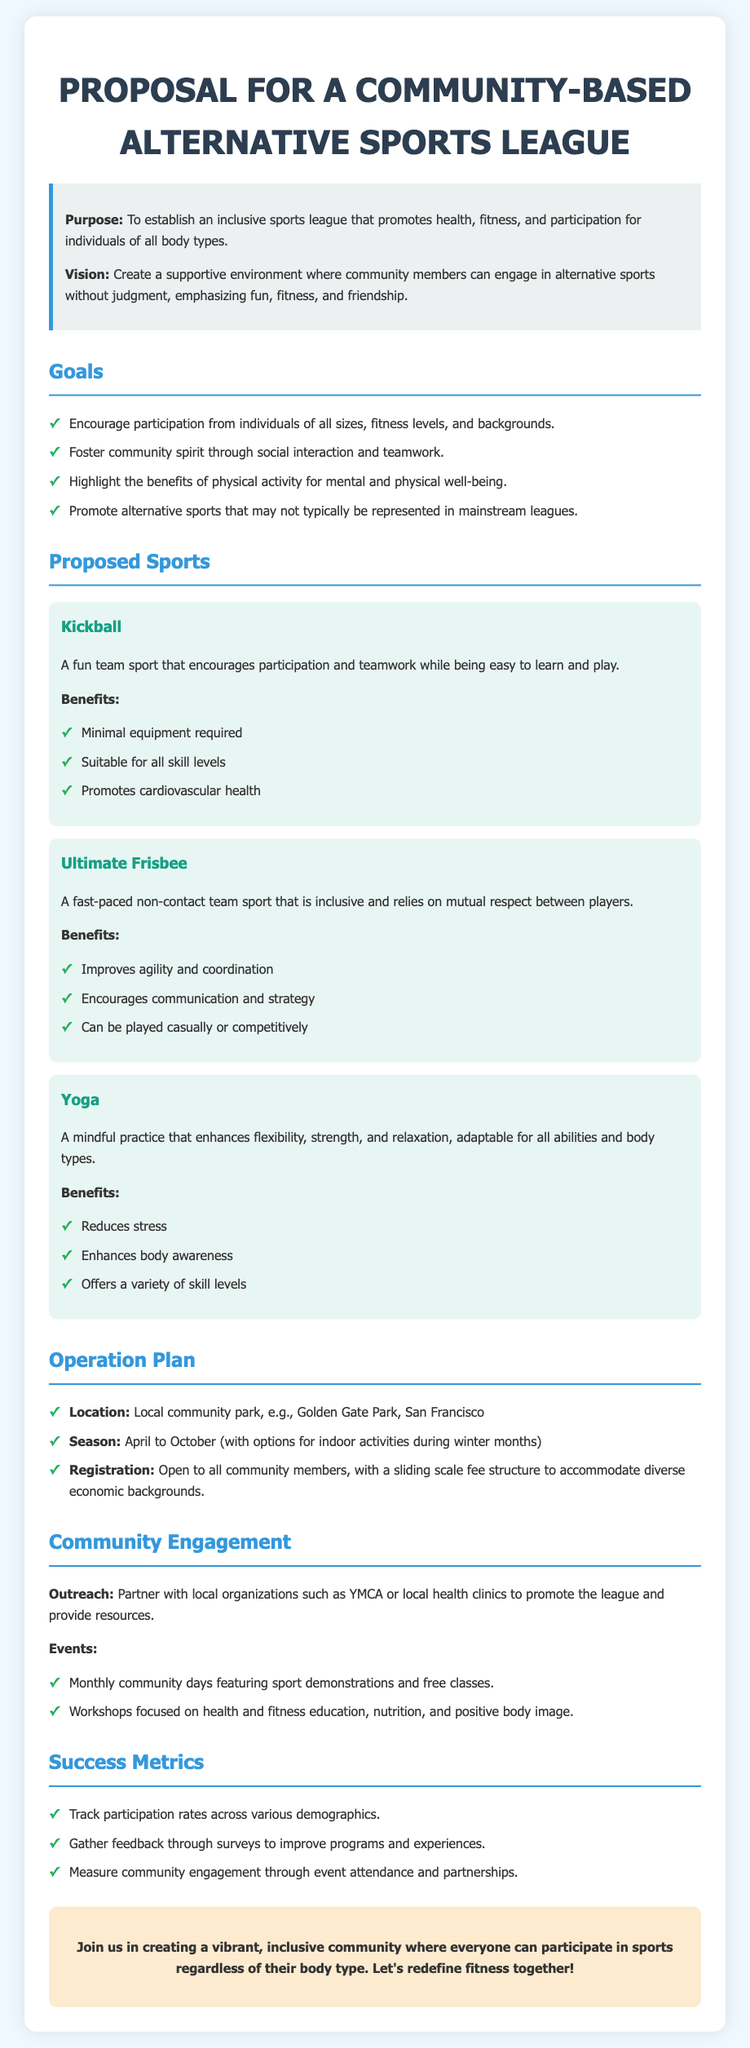What is the primary purpose of the league? The primary purpose is to establish an inclusive sports league that promotes health, fitness, and participation for individuals of all body types.
Answer: To establish an inclusive sports league What is the proposed location for the league? The document states that the league will be located in a local community park.
Answer: Local community park How many sports are proposed in the document? The document lists three proposed sports: Kickball, Ultimate Frisbee, and Yoga.
Answer: Three What is one benefit of playing Kickball? The document highlights several benefits, one of which is promoting cardiovascular health.
Answer: Promotes cardiovascular health During which months will the league operate? The league is planned to operate from April to October, with options for indoor activities during winter months.
Answer: April to October What strategy is suggested for community engagement? The document suggests partnering with local organizations to promote the league and provide resources.
Answer: Partnering with local organizations What are the success metrics mentioned in the proposal? The success metrics include tracking participation rates, gathering feedback through surveys, and measuring community engagement.
Answer: Track participation rates, gather feedback, measure community engagement What kind of events are planned for community engagement? Monthly community days featuring sport demonstrations and free classes are planned.
Answer: Monthly community days 